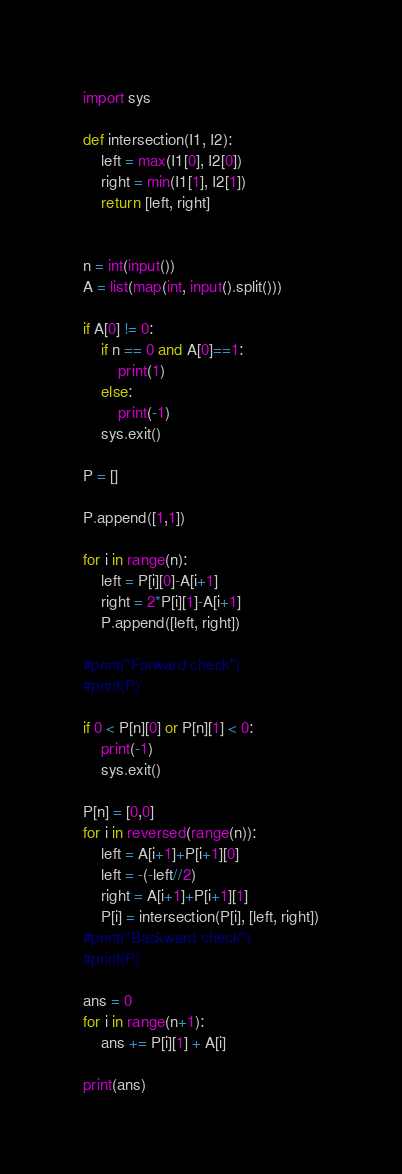<code> <loc_0><loc_0><loc_500><loc_500><_Python_>import sys

def intersection(I1, I2):
    left = max(I1[0], I2[0])
    right = min(I1[1], I2[1])
    return [left, right]


n = int(input())
A = list(map(int, input().split()))

if A[0] != 0:
    if n == 0 and A[0]==1:
        print(1)
    else:
        print(-1)
    sys.exit()

P = []

P.append([1,1])

for i in range(n):
    left = P[i][0]-A[i+1]
    right = 2*P[i][1]-A[i+1]
    P.append([left, right])

#print("Forward check")
#print(P)

if 0 < P[n][0] or P[n][1] < 0:
    print(-1)
    sys.exit()

P[n] = [0,0]
for i in reversed(range(n)):
    left = A[i+1]+P[i+1][0]
    left = -(-left//2)
    right = A[i+1]+P[i+1][1]
    P[i] = intersection(P[i], [left, right])
#print("Backward check")
#print(P)

ans = 0
for i in range(n+1):
    ans += P[i][1] + A[i]

print(ans)</code> 